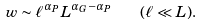<formula> <loc_0><loc_0><loc_500><loc_500>w \sim \ell ^ { \alpha _ { P } } L ^ { \alpha _ { G } - \alpha _ { P } } \quad ( \ell \ll L ) .</formula> 